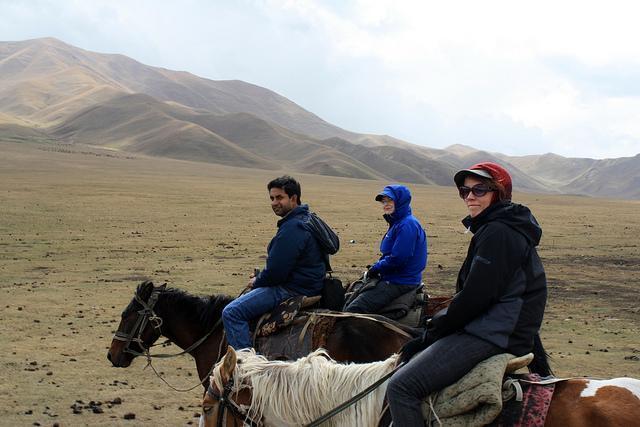How many people are wearing sunglasses?
Give a very brief answer. 1. How many people are there?
Give a very brief answer. 3. How many horses are there?
Give a very brief answer. 2. 